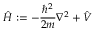Convert formula to latex. <formula><loc_0><loc_0><loc_500><loc_500>{ \hat { H } } \colon = - { \frac { \hbar { ^ } { 2 } } { 2 m } } \nabla ^ { 2 } + { \hat { V } }</formula> 